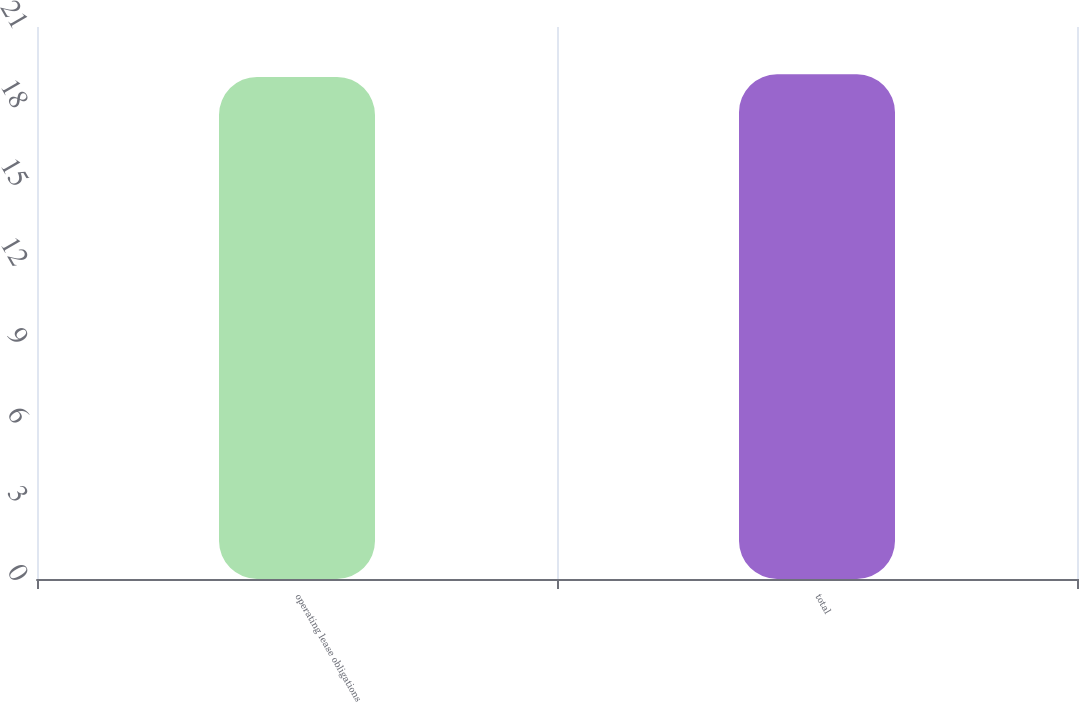Convert chart to OTSL. <chart><loc_0><loc_0><loc_500><loc_500><bar_chart><fcel>operating lease obligations<fcel>total<nl><fcel>19.1<fcel>19.2<nl></chart> 